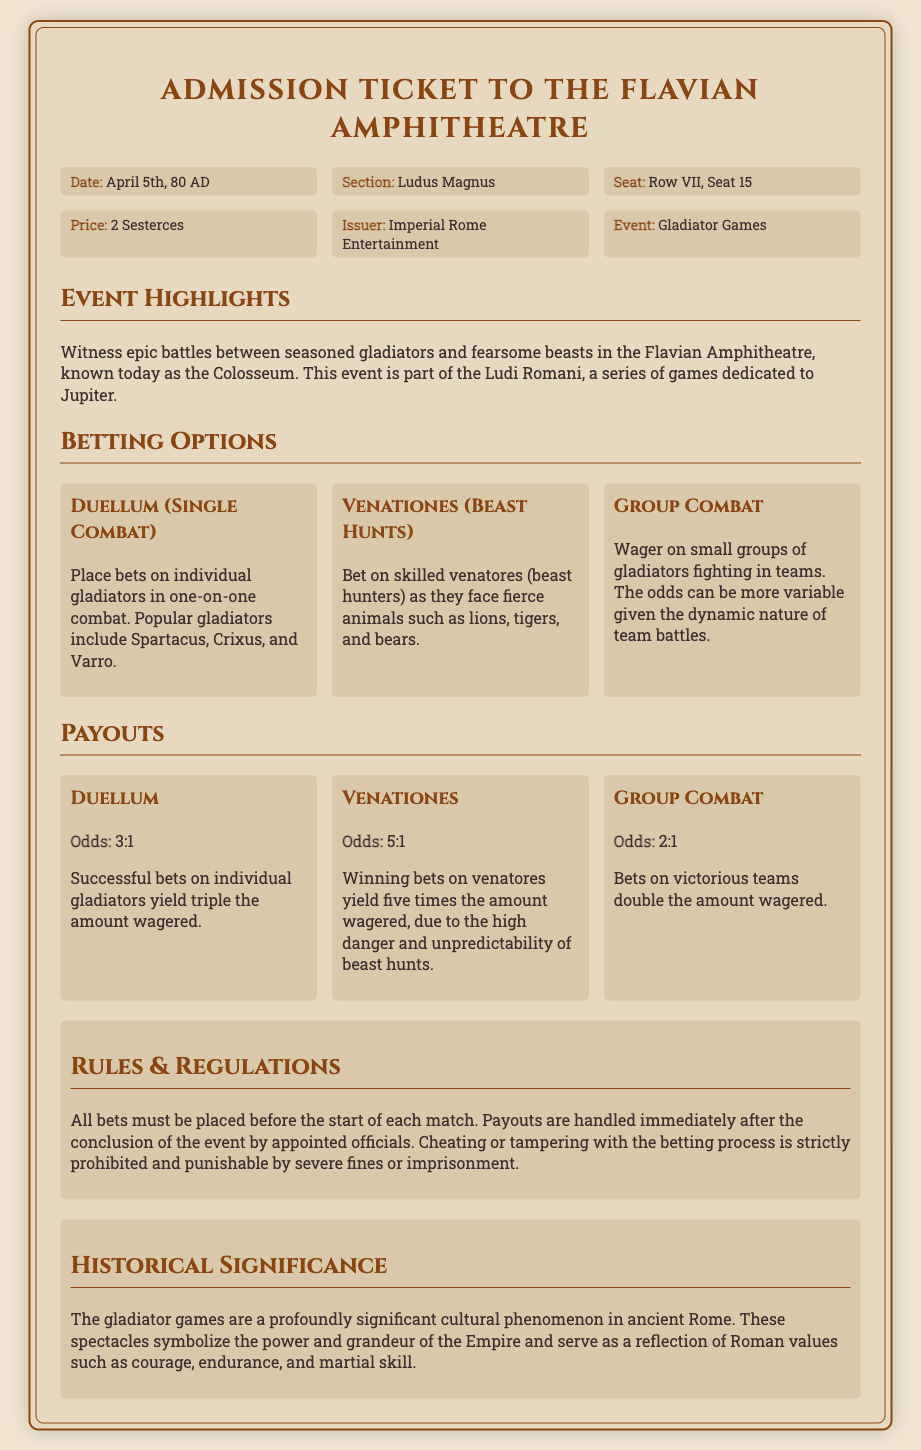what is the date of the event? The date of the event is explicitly mentioned in the ticket details as April 5th, 80 AD.
Answer: April 5th, 80 AD who is the issuer of the ticket? The issuer of the ticket is specified in the document as Imperial Rome Entertainment.
Answer: Imperial Rome Entertainment what is the price of the ticket? The price of the ticket is noted as 2 Sesterces.
Answer: 2 Sesterces what type of betting option has the highest odds? The betting option with the highest odds is Venationes, with odds of 5:1 for betting on beast hunts.
Answer: Venationes how much is the payout for a successful bet on Group Combat? The payout for successful bets on Group Combat is detailed as double the amount wagered, equating to odds of 2:1.
Answer: Double the amount wagered what are the rules regarding placing bets? The rules indicate that all bets must be placed before the start of each match.
Answer: Before the start of each match what type of events does the admission ticket pertain to? The admission ticket pertains to Gladiator Games, as mentioned in the event details.
Answer: Gladiator Games what is the section mentioned in the ticket? The section assigned in the ticket is noted as Ludus Magnus.
Answer: Ludus Magnus 